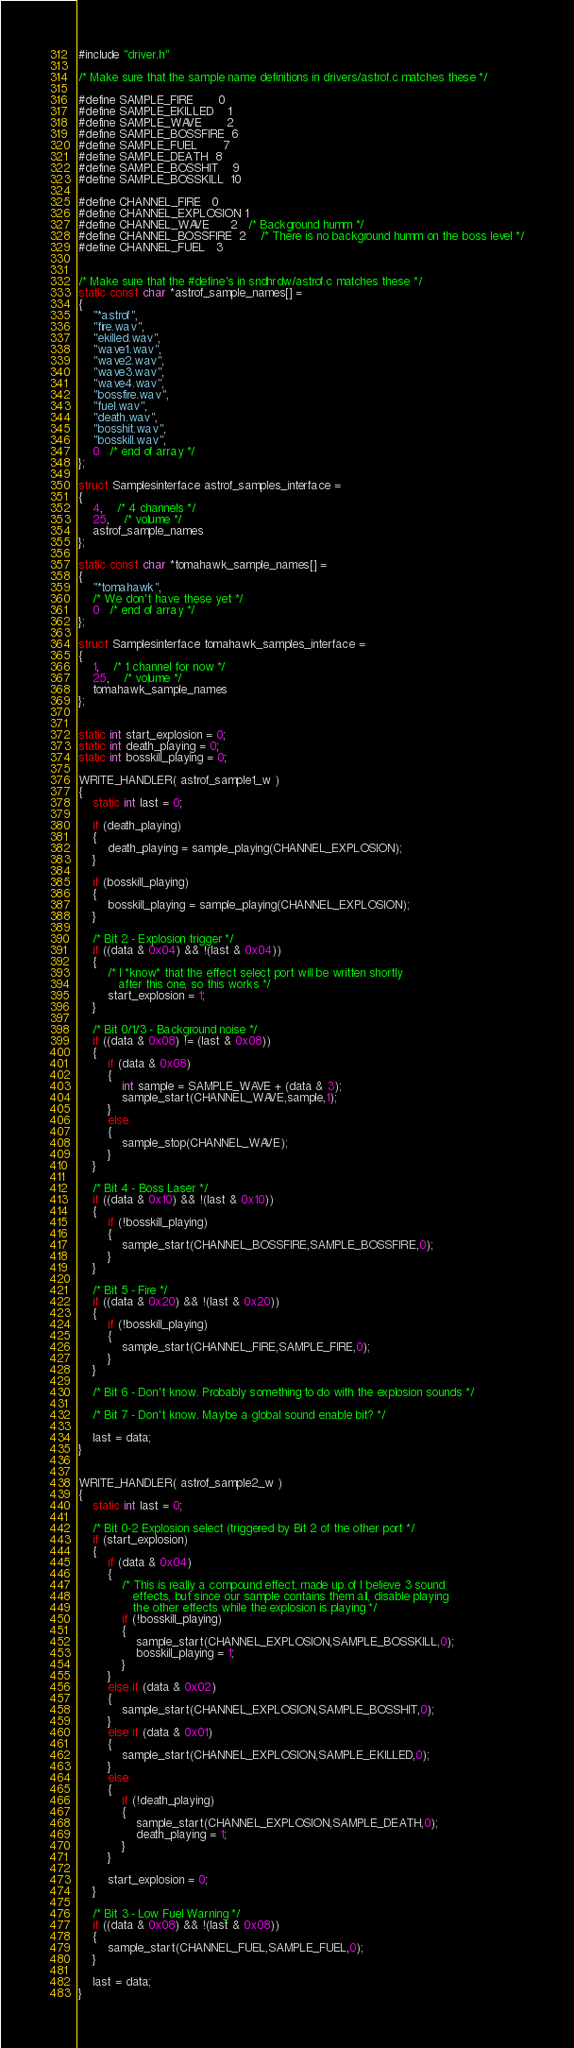<code> <loc_0><loc_0><loc_500><loc_500><_C++_>
#include "driver.h"

/* Make sure that the sample name definitions in drivers/astrof.c matches these */

#define SAMPLE_FIRE		 0
#define SAMPLE_EKILLED	 1
#define SAMPLE_WAVE		 2
#define SAMPLE_BOSSFIRE  6
#define SAMPLE_FUEL		 7
#define SAMPLE_DEATH	 8
#define SAMPLE_BOSSHIT	 9
#define SAMPLE_BOSSKILL  10

#define CHANNEL_FIRE	  0
#define CHANNEL_EXPLOSION 1
#define CHANNEL_WAVE      2   /* Background humm */
#define CHANNEL_BOSSFIRE  2	  /* There is no background humm on the boss level */
#define CHANNEL_FUEL	  3


/* Make sure that the #define's in sndhrdw/astrof.c matches these */
static const char *astrof_sample_names[] =
{
	"*astrof",
	"fire.wav",
	"ekilled.wav",
	"wave1.wav",
	"wave2.wav",
	"wave3.wav",
	"wave4.wav",
	"bossfire.wav",
	"fuel.wav",
	"death.wav",
	"bosshit.wav",
	"bosskill.wav",
	0   /* end of array */
};

struct Samplesinterface astrof_samples_interface =
{
	4,	/* 4 channels */
	25,	/* volume */
	astrof_sample_names
};

static const char *tomahawk_sample_names[] =
{
	"*tomahawk",
	/* We don't have these yet */
	0   /* end of array */
};

struct Samplesinterface tomahawk_samples_interface =
{
	1,	/* 1 channel for now */
	25,	/* volume */
	tomahawk_sample_names
};


static int start_explosion = 0;
static int death_playing = 0;
static int bosskill_playing = 0;

WRITE_HANDLER( astrof_sample1_w )
{
	static int last = 0;

	if (death_playing)
	{
		death_playing = sample_playing(CHANNEL_EXPLOSION);
	}

	if (bosskill_playing)
	{
		bosskill_playing = sample_playing(CHANNEL_EXPLOSION);
	}

	/* Bit 2 - Explosion trigger */
	if ((data & 0x04) && !(last & 0x04))
	{
		/* I *know* that the effect select port will be written shortly
		   after this one, so this works */
		start_explosion = 1;
	}

	/* Bit 0/1/3 - Background noise */
	if ((data & 0x08) != (last & 0x08))
	{
		if (data & 0x08)
		{
			int sample = SAMPLE_WAVE + (data & 3);
			sample_start(CHANNEL_WAVE,sample,1);
		}
		else
		{
			sample_stop(CHANNEL_WAVE);
		}
	}

	/* Bit 4 - Boss Laser */
	if ((data & 0x10) && !(last & 0x10))
	{
		if (!bosskill_playing)
		{
			sample_start(CHANNEL_BOSSFIRE,SAMPLE_BOSSFIRE,0);
		}
	}

	/* Bit 5 - Fire */
	if ((data & 0x20) && !(last & 0x20))
	{
		if (!bosskill_playing)
		{
			sample_start(CHANNEL_FIRE,SAMPLE_FIRE,0);
		}
	}

	/* Bit 6 - Don't know. Probably something to do with the explosion sounds */

	/* Bit 7 - Don't know. Maybe a global sound enable bit? */

	last = data;
}


WRITE_HANDLER( astrof_sample2_w )
{
	static int last = 0;

	/* Bit 0-2 Explosion select (triggered by Bit 2 of the other port */
	if (start_explosion)
	{
		if (data & 0x04)
		{
			/* This is really a compound effect, made up of I believe 3 sound
			   effects, but since our sample contains them all, disable playing
			   the other effects while the explosion is playing */
			if (!bosskill_playing)
			{
				sample_start(CHANNEL_EXPLOSION,SAMPLE_BOSSKILL,0);
				bosskill_playing = 1;
			}
		}
		else if (data & 0x02)
		{
			sample_start(CHANNEL_EXPLOSION,SAMPLE_BOSSHIT,0);
		}
		else if (data & 0x01)
		{
			sample_start(CHANNEL_EXPLOSION,SAMPLE_EKILLED,0);
		}
		else
		{
			if (!death_playing)
			{
				sample_start(CHANNEL_EXPLOSION,SAMPLE_DEATH,0);
				death_playing = 1;
			}
		}

		start_explosion = 0;
	}

	/* Bit 3 - Low Fuel Warning */
	if ((data & 0x08) && !(last & 0x08))
	{
		sample_start(CHANNEL_FUEL,SAMPLE_FUEL,0);
	}

	last = data;
}

</code> 